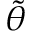Convert formula to latex. <formula><loc_0><loc_0><loc_500><loc_500>\tilde { \theta }</formula> 